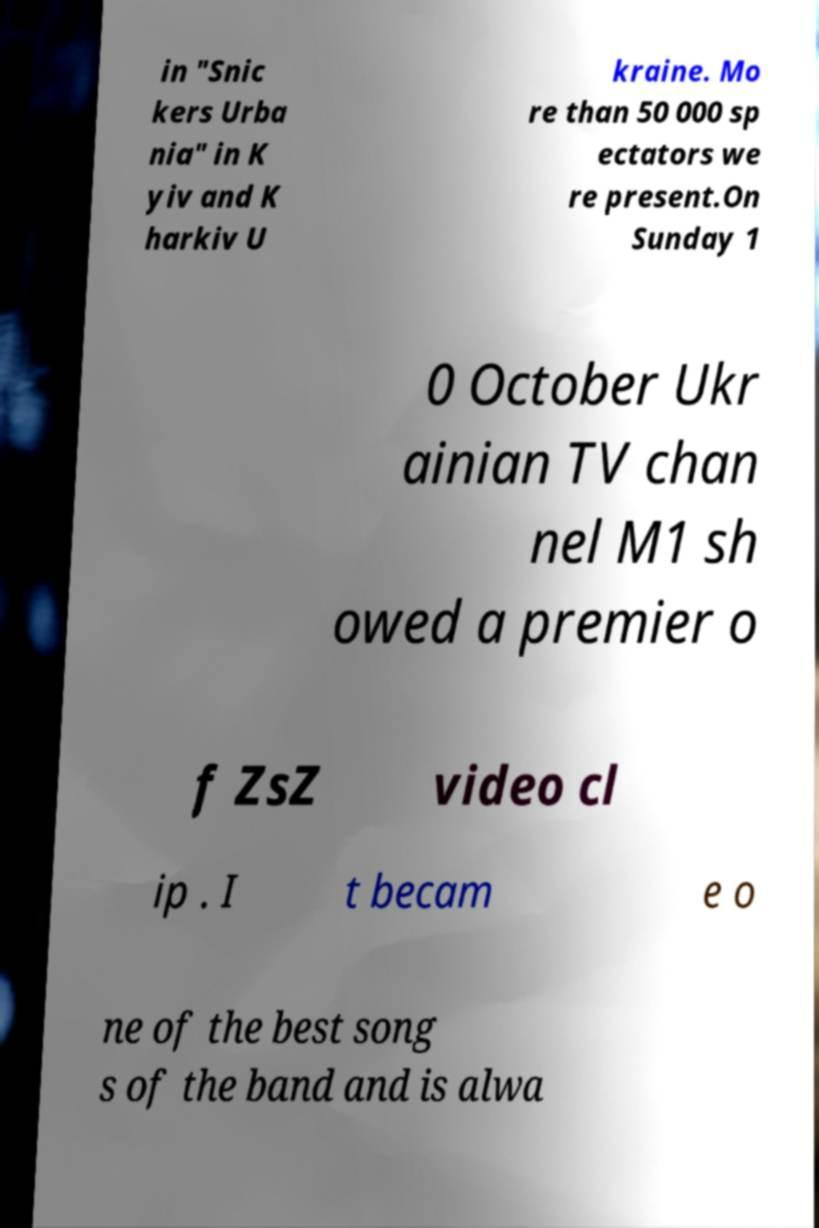I need the written content from this picture converted into text. Can you do that? in "Snic kers Urba nia" in K yiv and K harkiv U kraine. Mo re than 50 000 sp ectators we re present.On Sunday 1 0 October Ukr ainian TV chan nel M1 sh owed a premier o f ZsZ video cl ip . I t becam e o ne of the best song s of the band and is alwa 